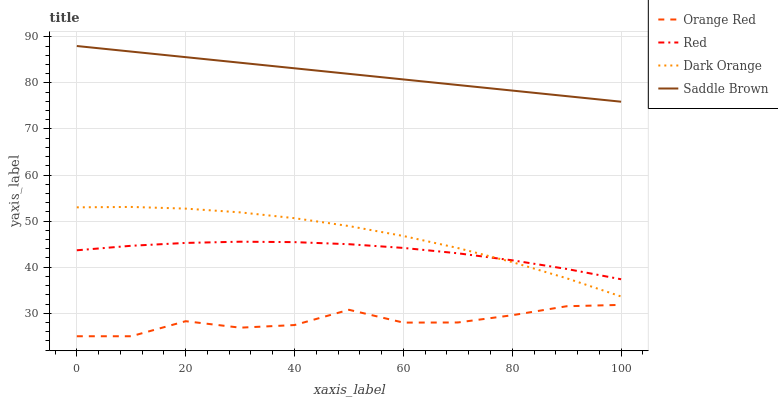Does Orange Red have the minimum area under the curve?
Answer yes or no. Yes. Does Saddle Brown have the maximum area under the curve?
Answer yes or no. Yes. Does Red have the minimum area under the curve?
Answer yes or no. No. Does Red have the maximum area under the curve?
Answer yes or no. No. Is Saddle Brown the smoothest?
Answer yes or no. Yes. Is Orange Red the roughest?
Answer yes or no. Yes. Is Red the smoothest?
Answer yes or no. No. Is Red the roughest?
Answer yes or no. No. Does Orange Red have the lowest value?
Answer yes or no. Yes. Does Red have the lowest value?
Answer yes or no. No. Does Saddle Brown have the highest value?
Answer yes or no. Yes. Does Red have the highest value?
Answer yes or no. No. Is Orange Red less than Saddle Brown?
Answer yes or no. Yes. Is Saddle Brown greater than Dark Orange?
Answer yes or no. Yes. Does Red intersect Dark Orange?
Answer yes or no. Yes. Is Red less than Dark Orange?
Answer yes or no. No. Is Red greater than Dark Orange?
Answer yes or no. No. Does Orange Red intersect Saddle Brown?
Answer yes or no. No. 